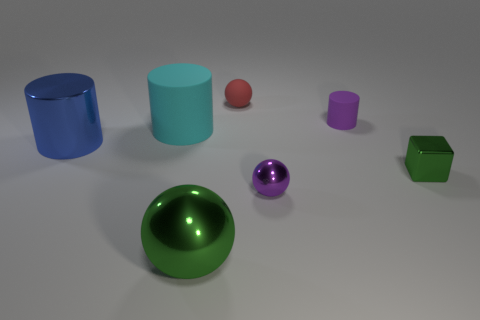The metallic thing that is the same color as the big sphere is what size?
Offer a very short reply. Small. Are there any other things that have the same material as the green cube?
Your response must be concise. Yes. Is the number of rubber objects behind the big green object less than the number of big balls?
Provide a succinct answer. No. The large shiny object that is to the left of the large metallic object on the right side of the big rubber object is what color?
Your answer should be very brief. Blue. There is a object in front of the small metal object to the left of the green thing that is on the right side of the large metal ball; what size is it?
Offer a terse response. Large. Are there fewer big green shiny balls that are behind the big green metallic object than big cylinders in front of the tiny green thing?
Your answer should be very brief. No. What number of green objects are made of the same material as the blue cylinder?
Offer a terse response. 2. There is a green thing left of the purple thing behind the large blue object; are there any big objects that are in front of it?
Ensure brevity in your answer.  No. There is another green thing that is made of the same material as the small green thing; what is its shape?
Offer a very short reply. Sphere. Are there more small purple metal spheres than green matte cylinders?
Offer a very short reply. Yes. 